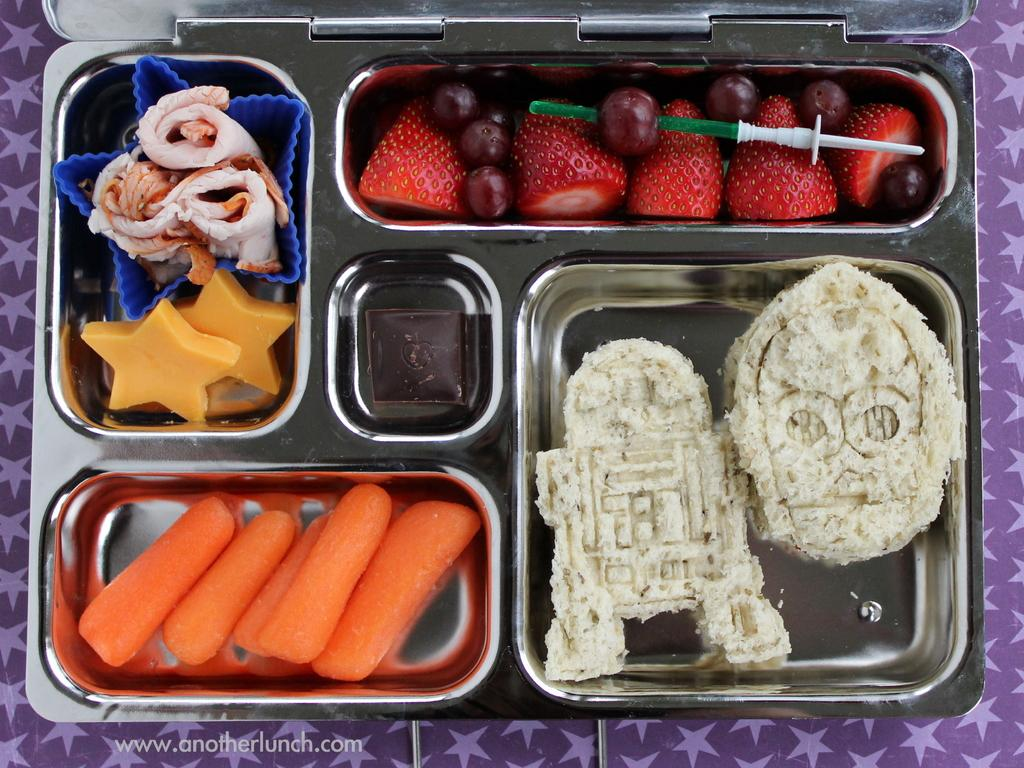What is present in the image? There are food items in the image. What is the food items placed on? The food items are on a steel plate. Can you describe the colors of the food items? The food items have various colors, including orange, white, red, brown, yellow, and cream. What color is the background of the image? The background of the image is in purple color. Can you see any owls or fairies in the image? No, there are no owls or fairies present in the image. 